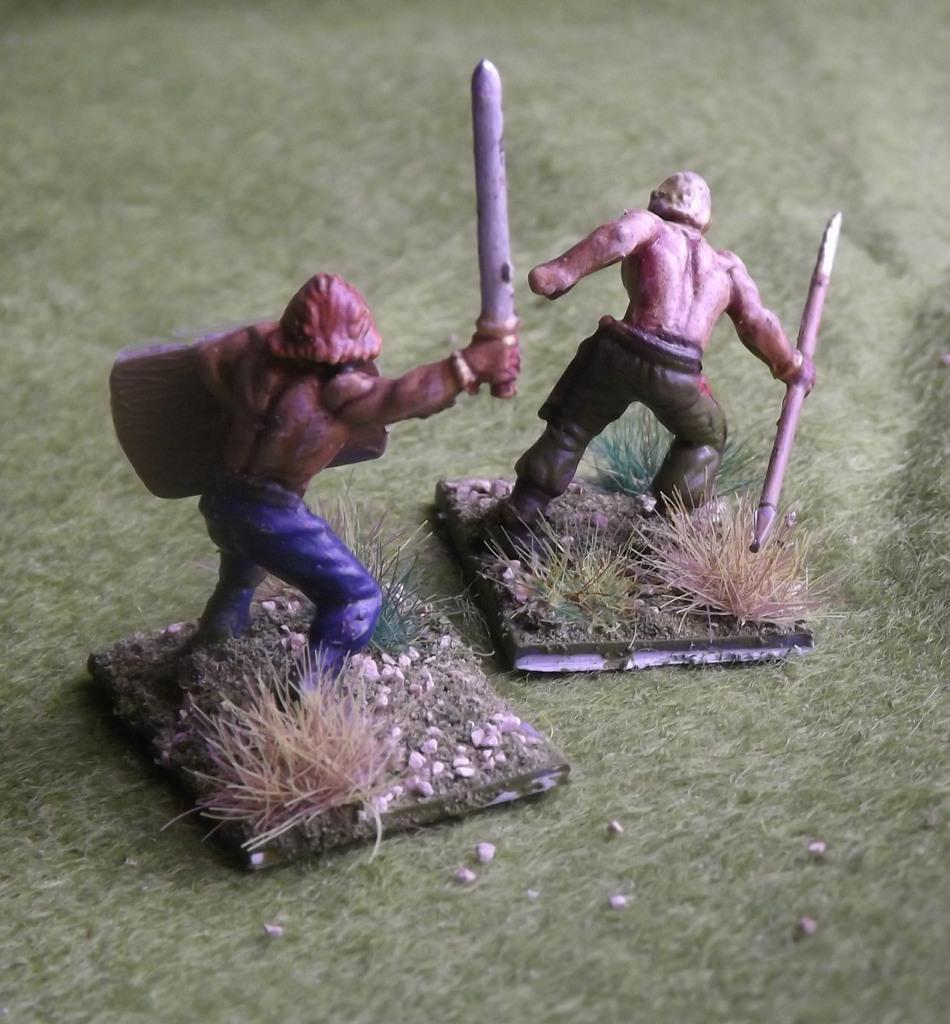Could you give a brief overview of what you see in this image? In this image we can see two toys, grass, stones, which are on the mat. 